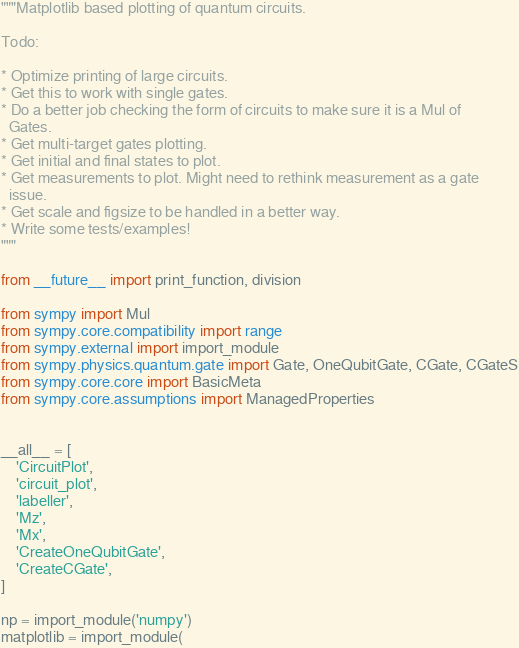Convert code to text. <code><loc_0><loc_0><loc_500><loc_500><_Python_>"""Matplotlib based plotting of quantum circuits.

Todo:

* Optimize printing of large circuits.
* Get this to work with single gates.
* Do a better job checking the form of circuits to make sure it is a Mul of
  Gates.
* Get multi-target gates plotting.
* Get initial and final states to plot.
* Get measurements to plot. Might need to rethink measurement as a gate
  issue.
* Get scale and figsize to be handled in a better way.
* Write some tests/examples!
"""

from __future__ import print_function, division

from sympy import Mul
from sympy.core.compatibility import range
from sympy.external import import_module
from sympy.physics.quantum.gate import Gate, OneQubitGate, CGate, CGateS
from sympy.core.core import BasicMeta
from sympy.core.assumptions import ManagedProperties


__all__ = [
    'CircuitPlot',
    'circuit_plot',
    'labeller',
    'Mz',
    'Mx',
    'CreateOneQubitGate',
    'CreateCGate',
]

np = import_module('numpy')
matplotlib = import_module(</code> 